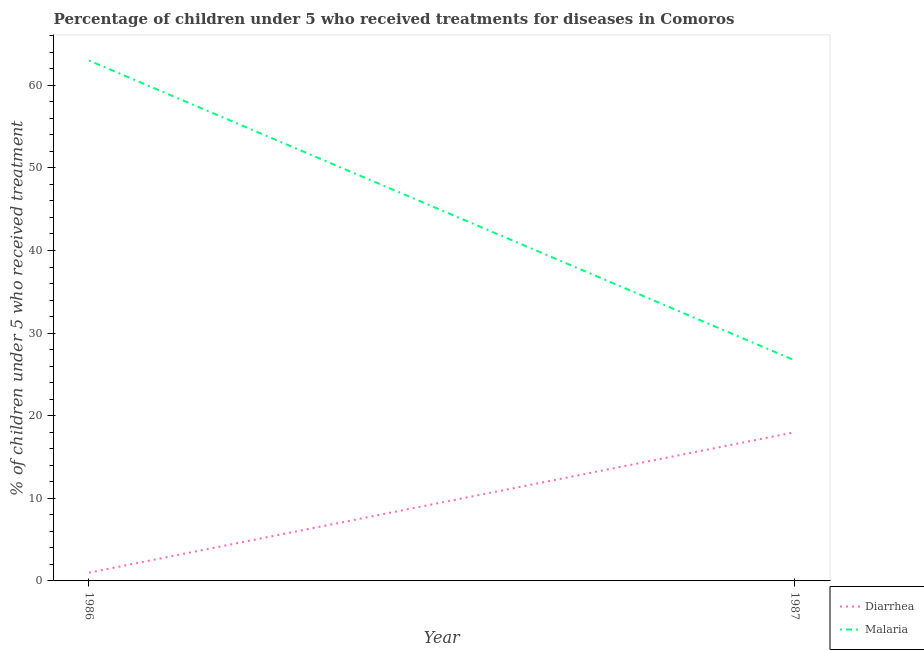How many different coloured lines are there?
Your response must be concise. 2. Does the line corresponding to percentage of children who received treatment for diarrhoea intersect with the line corresponding to percentage of children who received treatment for malaria?
Offer a terse response. No. Is the number of lines equal to the number of legend labels?
Give a very brief answer. Yes. What is the percentage of children who received treatment for diarrhoea in 1987?
Give a very brief answer. 18. Across all years, what is the minimum percentage of children who received treatment for malaria?
Your answer should be very brief. 26.7. What is the total percentage of children who received treatment for malaria in the graph?
Offer a very short reply. 89.7. What is the difference between the percentage of children who received treatment for diarrhoea in 1986 and that in 1987?
Offer a very short reply. -17. In the year 1986, what is the difference between the percentage of children who received treatment for diarrhoea and percentage of children who received treatment for malaria?
Your response must be concise. -62. In how many years, is the percentage of children who received treatment for malaria greater than 4 %?
Your response must be concise. 2. What is the ratio of the percentage of children who received treatment for malaria in 1986 to that in 1987?
Provide a succinct answer. 2.36. In how many years, is the percentage of children who received treatment for diarrhoea greater than the average percentage of children who received treatment for diarrhoea taken over all years?
Provide a short and direct response. 1. Does the percentage of children who received treatment for malaria monotonically increase over the years?
Provide a short and direct response. No. Is the percentage of children who received treatment for malaria strictly greater than the percentage of children who received treatment for diarrhoea over the years?
Offer a terse response. Yes. Is the percentage of children who received treatment for diarrhoea strictly less than the percentage of children who received treatment for malaria over the years?
Make the answer very short. Yes. What is the difference between two consecutive major ticks on the Y-axis?
Your answer should be very brief. 10. Does the graph contain any zero values?
Make the answer very short. No. Does the graph contain grids?
Give a very brief answer. No. Where does the legend appear in the graph?
Your answer should be very brief. Bottom right. How are the legend labels stacked?
Make the answer very short. Vertical. What is the title of the graph?
Ensure brevity in your answer.  Percentage of children under 5 who received treatments for diseases in Comoros. What is the label or title of the Y-axis?
Keep it short and to the point. % of children under 5 who received treatment. What is the % of children under 5 who received treatment in Diarrhea in 1986?
Your answer should be very brief. 1. What is the % of children under 5 who received treatment in Malaria in 1987?
Provide a short and direct response. 26.7. Across all years, what is the maximum % of children under 5 who received treatment of Diarrhea?
Ensure brevity in your answer.  18. Across all years, what is the minimum % of children under 5 who received treatment of Diarrhea?
Ensure brevity in your answer.  1. Across all years, what is the minimum % of children under 5 who received treatment in Malaria?
Offer a very short reply. 26.7. What is the total % of children under 5 who received treatment of Malaria in the graph?
Give a very brief answer. 89.7. What is the difference between the % of children under 5 who received treatment of Malaria in 1986 and that in 1987?
Provide a succinct answer. 36.3. What is the difference between the % of children under 5 who received treatment of Diarrhea in 1986 and the % of children under 5 who received treatment of Malaria in 1987?
Offer a terse response. -25.7. What is the average % of children under 5 who received treatment of Diarrhea per year?
Your answer should be very brief. 9.5. What is the average % of children under 5 who received treatment of Malaria per year?
Provide a short and direct response. 44.85. In the year 1986, what is the difference between the % of children under 5 who received treatment in Diarrhea and % of children under 5 who received treatment in Malaria?
Offer a very short reply. -62. What is the ratio of the % of children under 5 who received treatment in Diarrhea in 1986 to that in 1987?
Provide a short and direct response. 0.06. What is the ratio of the % of children under 5 who received treatment of Malaria in 1986 to that in 1987?
Give a very brief answer. 2.36. What is the difference between the highest and the second highest % of children under 5 who received treatment of Malaria?
Your response must be concise. 36.3. What is the difference between the highest and the lowest % of children under 5 who received treatment of Malaria?
Your response must be concise. 36.3. 